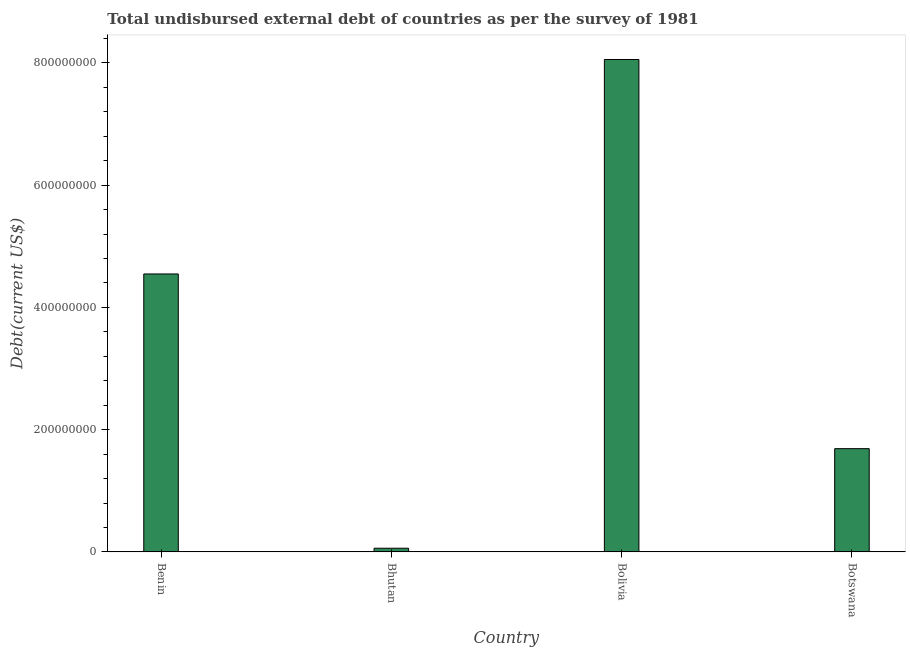Does the graph contain any zero values?
Provide a short and direct response. No. Does the graph contain grids?
Your response must be concise. No. What is the title of the graph?
Offer a terse response. Total undisbursed external debt of countries as per the survey of 1981. What is the label or title of the X-axis?
Make the answer very short. Country. What is the label or title of the Y-axis?
Offer a very short reply. Debt(current US$). What is the total debt in Botswana?
Keep it short and to the point. 1.69e+08. Across all countries, what is the maximum total debt?
Make the answer very short. 8.06e+08. Across all countries, what is the minimum total debt?
Offer a very short reply. 6.02e+06. In which country was the total debt maximum?
Ensure brevity in your answer.  Bolivia. In which country was the total debt minimum?
Keep it short and to the point. Bhutan. What is the sum of the total debt?
Provide a succinct answer. 1.44e+09. What is the difference between the total debt in Benin and Bolivia?
Provide a short and direct response. -3.51e+08. What is the average total debt per country?
Your response must be concise. 3.59e+08. What is the median total debt?
Provide a succinct answer. 3.12e+08. What is the ratio of the total debt in Bhutan to that in Botswana?
Give a very brief answer. 0.04. Is the total debt in Bhutan less than that in Botswana?
Keep it short and to the point. Yes. Is the difference between the total debt in Benin and Bolivia greater than the difference between any two countries?
Give a very brief answer. No. What is the difference between the highest and the second highest total debt?
Keep it short and to the point. 3.51e+08. What is the difference between the highest and the lowest total debt?
Your answer should be compact. 8.00e+08. In how many countries, is the total debt greater than the average total debt taken over all countries?
Make the answer very short. 2. Are all the bars in the graph horizontal?
Your answer should be very brief. No. How many countries are there in the graph?
Your answer should be very brief. 4. What is the difference between two consecutive major ticks on the Y-axis?
Ensure brevity in your answer.  2.00e+08. Are the values on the major ticks of Y-axis written in scientific E-notation?
Ensure brevity in your answer.  No. What is the Debt(current US$) of Benin?
Make the answer very short. 4.55e+08. What is the Debt(current US$) in Bhutan?
Make the answer very short. 6.02e+06. What is the Debt(current US$) of Bolivia?
Offer a very short reply. 8.06e+08. What is the Debt(current US$) in Botswana?
Your answer should be very brief. 1.69e+08. What is the difference between the Debt(current US$) in Benin and Bhutan?
Provide a short and direct response. 4.49e+08. What is the difference between the Debt(current US$) in Benin and Bolivia?
Give a very brief answer. -3.51e+08. What is the difference between the Debt(current US$) in Benin and Botswana?
Your response must be concise. 2.86e+08. What is the difference between the Debt(current US$) in Bhutan and Bolivia?
Provide a succinct answer. -8.00e+08. What is the difference between the Debt(current US$) in Bhutan and Botswana?
Provide a short and direct response. -1.63e+08. What is the difference between the Debt(current US$) in Bolivia and Botswana?
Provide a succinct answer. 6.37e+08. What is the ratio of the Debt(current US$) in Benin to that in Bhutan?
Give a very brief answer. 75.56. What is the ratio of the Debt(current US$) in Benin to that in Bolivia?
Provide a short and direct response. 0.56. What is the ratio of the Debt(current US$) in Benin to that in Botswana?
Provide a short and direct response. 2.69. What is the ratio of the Debt(current US$) in Bhutan to that in Bolivia?
Keep it short and to the point. 0.01. What is the ratio of the Debt(current US$) in Bhutan to that in Botswana?
Give a very brief answer. 0.04. What is the ratio of the Debt(current US$) in Bolivia to that in Botswana?
Offer a very short reply. 4.77. 